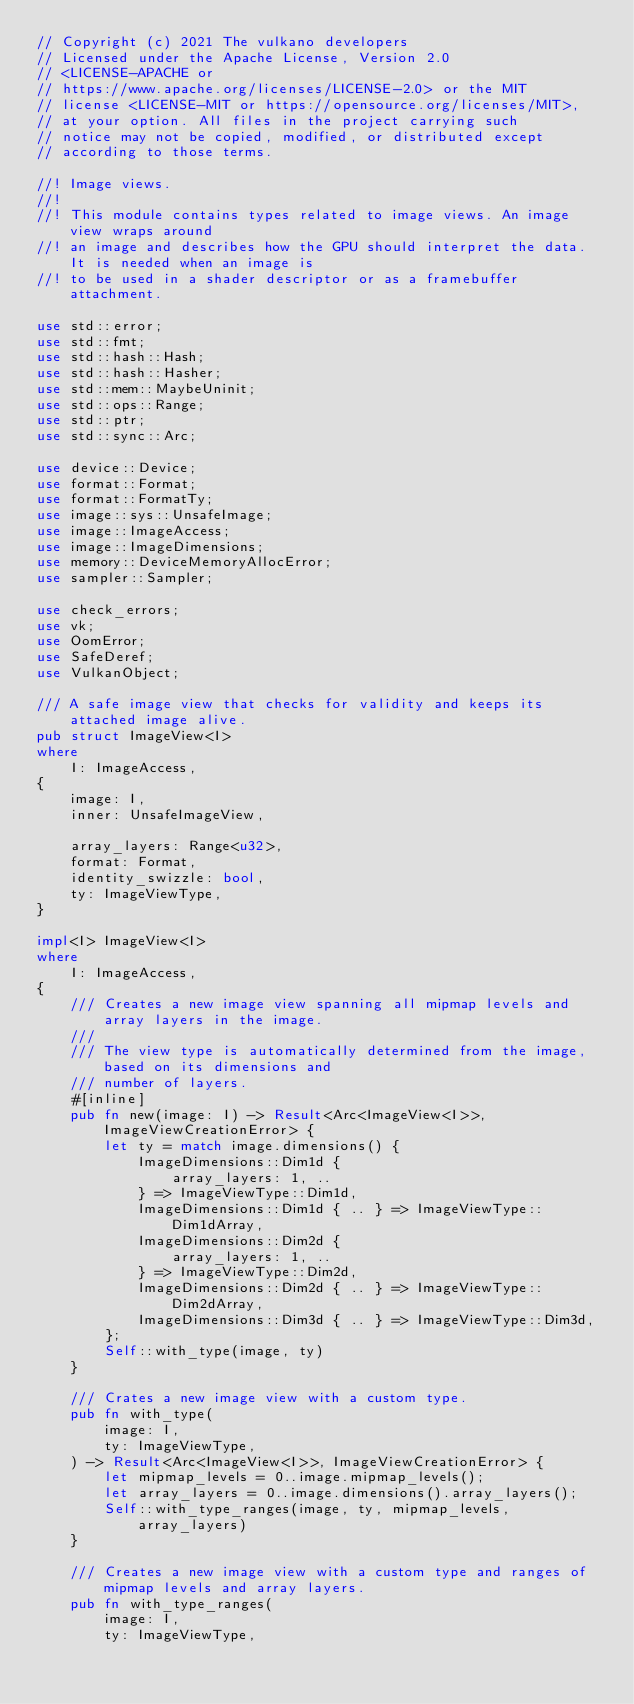<code> <loc_0><loc_0><loc_500><loc_500><_Rust_>// Copyright (c) 2021 The vulkano developers
// Licensed under the Apache License, Version 2.0
// <LICENSE-APACHE or
// https://www.apache.org/licenses/LICENSE-2.0> or the MIT
// license <LICENSE-MIT or https://opensource.org/licenses/MIT>,
// at your option. All files in the project carrying such
// notice may not be copied, modified, or distributed except
// according to those terms.

//! Image views.
//!
//! This module contains types related to image views. An image view wraps around
//! an image and describes how the GPU should interpret the data. It is needed when an image is
//! to be used in a shader descriptor or as a framebuffer attachment.

use std::error;
use std::fmt;
use std::hash::Hash;
use std::hash::Hasher;
use std::mem::MaybeUninit;
use std::ops::Range;
use std::ptr;
use std::sync::Arc;

use device::Device;
use format::Format;
use format::FormatTy;
use image::sys::UnsafeImage;
use image::ImageAccess;
use image::ImageDimensions;
use memory::DeviceMemoryAllocError;
use sampler::Sampler;

use check_errors;
use vk;
use OomError;
use SafeDeref;
use VulkanObject;

/// A safe image view that checks for validity and keeps its attached image alive.
pub struct ImageView<I>
where
    I: ImageAccess,
{
    image: I,
    inner: UnsafeImageView,

    array_layers: Range<u32>,
    format: Format,
    identity_swizzle: bool,
    ty: ImageViewType,
}

impl<I> ImageView<I>
where
    I: ImageAccess,
{
    /// Creates a new image view spanning all mipmap levels and array layers in the image.
    ///
    /// The view type is automatically determined from the image, based on its dimensions and
    /// number of layers.
    #[inline]
    pub fn new(image: I) -> Result<Arc<ImageView<I>>, ImageViewCreationError> {
        let ty = match image.dimensions() {
            ImageDimensions::Dim1d {
                array_layers: 1, ..
            } => ImageViewType::Dim1d,
            ImageDimensions::Dim1d { .. } => ImageViewType::Dim1dArray,
            ImageDimensions::Dim2d {
                array_layers: 1, ..
            } => ImageViewType::Dim2d,
            ImageDimensions::Dim2d { .. } => ImageViewType::Dim2dArray,
            ImageDimensions::Dim3d { .. } => ImageViewType::Dim3d,
        };
        Self::with_type(image, ty)
    }

    /// Crates a new image view with a custom type.
    pub fn with_type(
        image: I,
        ty: ImageViewType,
    ) -> Result<Arc<ImageView<I>>, ImageViewCreationError> {
        let mipmap_levels = 0..image.mipmap_levels();
        let array_layers = 0..image.dimensions().array_layers();
        Self::with_type_ranges(image, ty, mipmap_levels, array_layers)
    }

    /// Creates a new image view with a custom type and ranges of mipmap levels and array layers.
    pub fn with_type_ranges(
        image: I,
        ty: ImageViewType,</code> 